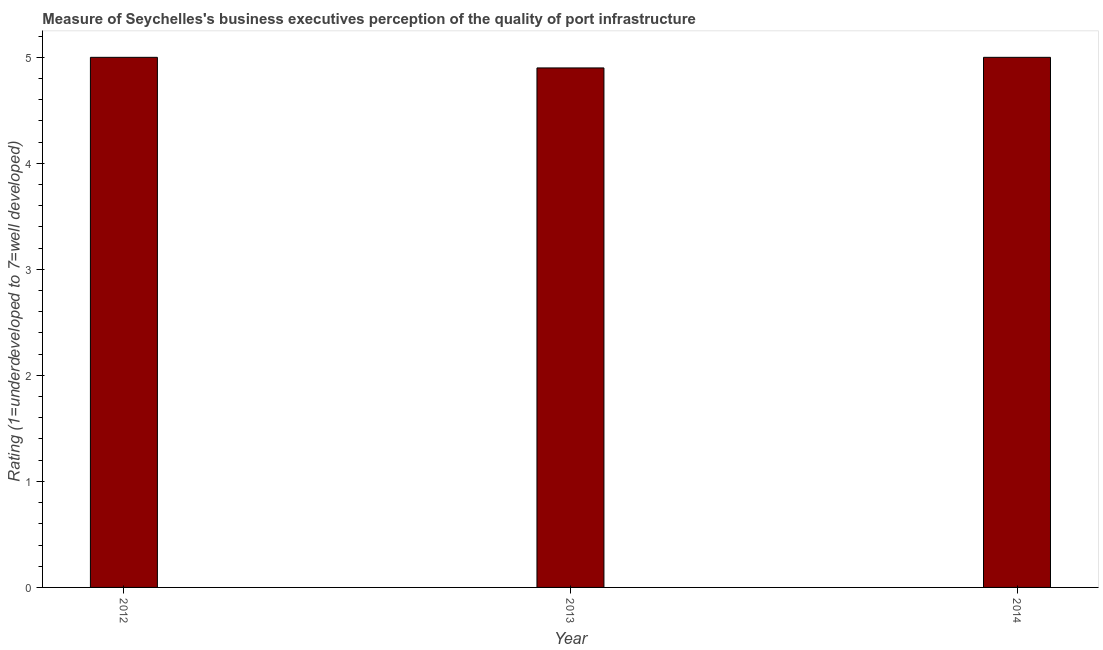Does the graph contain any zero values?
Your answer should be very brief. No. What is the title of the graph?
Keep it short and to the point. Measure of Seychelles's business executives perception of the quality of port infrastructure. What is the label or title of the X-axis?
Provide a short and direct response. Year. What is the label or title of the Y-axis?
Make the answer very short. Rating (1=underdeveloped to 7=well developed) . What is the rating measuring quality of port infrastructure in 2014?
Provide a succinct answer. 5. Across all years, what is the maximum rating measuring quality of port infrastructure?
Give a very brief answer. 5. What is the sum of the rating measuring quality of port infrastructure?
Offer a terse response. 14.9. What is the average rating measuring quality of port infrastructure per year?
Give a very brief answer. 4.97. What is the median rating measuring quality of port infrastructure?
Provide a succinct answer. 5. What is the ratio of the rating measuring quality of port infrastructure in 2013 to that in 2014?
Keep it short and to the point. 0.98. What is the difference between the highest and the lowest rating measuring quality of port infrastructure?
Offer a very short reply. 0.1. In how many years, is the rating measuring quality of port infrastructure greater than the average rating measuring quality of port infrastructure taken over all years?
Make the answer very short. 2. How many bars are there?
Provide a succinct answer. 3. Are all the bars in the graph horizontal?
Make the answer very short. No. What is the difference between two consecutive major ticks on the Y-axis?
Keep it short and to the point. 1. Are the values on the major ticks of Y-axis written in scientific E-notation?
Offer a terse response. No. What is the difference between the Rating (1=underdeveloped to 7=well developed)  in 2012 and 2014?
Provide a short and direct response. 0. What is the ratio of the Rating (1=underdeveloped to 7=well developed)  in 2013 to that in 2014?
Ensure brevity in your answer.  0.98. 